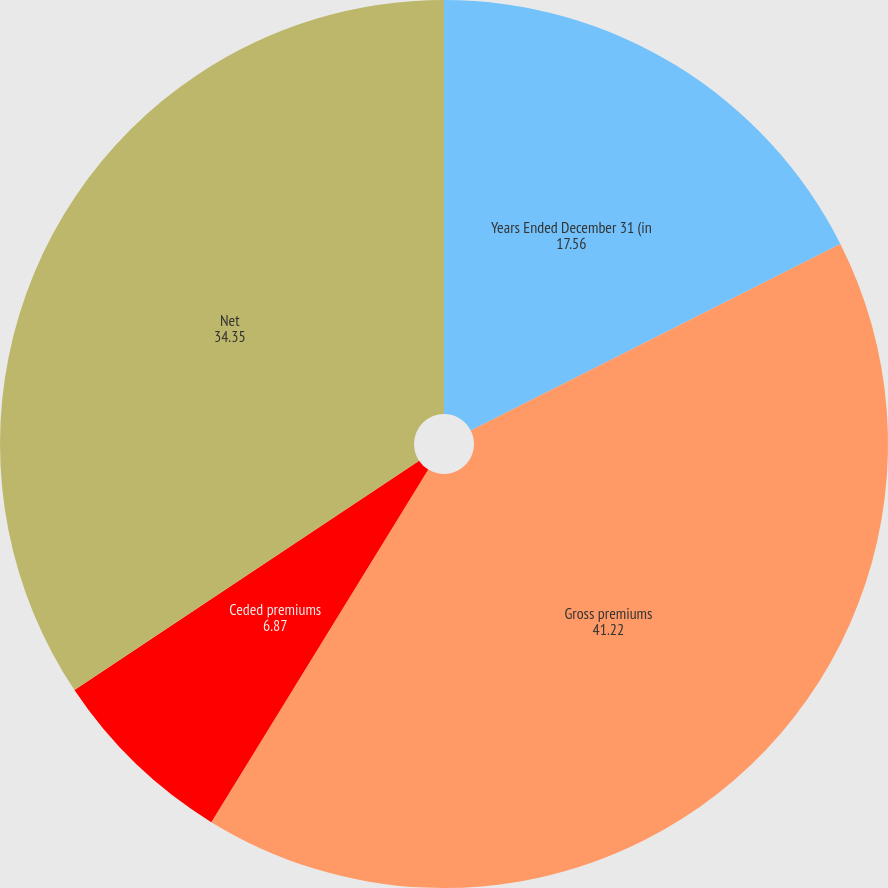<chart> <loc_0><loc_0><loc_500><loc_500><pie_chart><fcel>Years Ended December 31 (in<fcel>Gross premiums<fcel>Ceded premiums<fcel>Net<nl><fcel>17.56%<fcel>41.22%<fcel>6.87%<fcel>34.35%<nl></chart> 